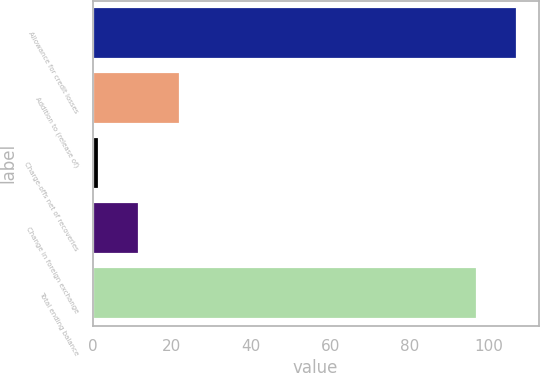Convert chart. <chart><loc_0><loc_0><loc_500><loc_500><bar_chart><fcel>Allowance for credit losses<fcel>Addition to (release of)<fcel>Charge-offs net of recoveries<fcel>Change in foreign exchange<fcel>Total ending balance<nl><fcel>107.25<fcel>22.05<fcel>1.55<fcel>11.8<fcel>97<nl></chart> 